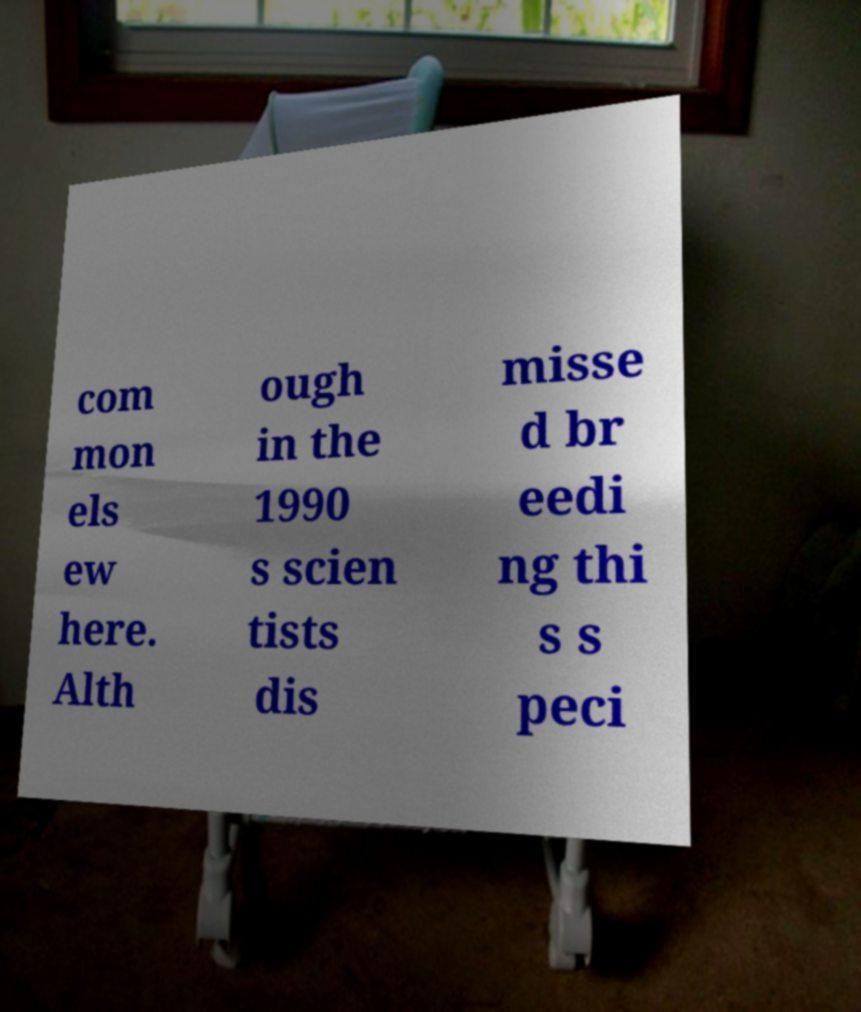Could you extract and type out the text from this image? com mon els ew here. Alth ough in the 1990 s scien tists dis misse d br eedi ng thi s s peci 